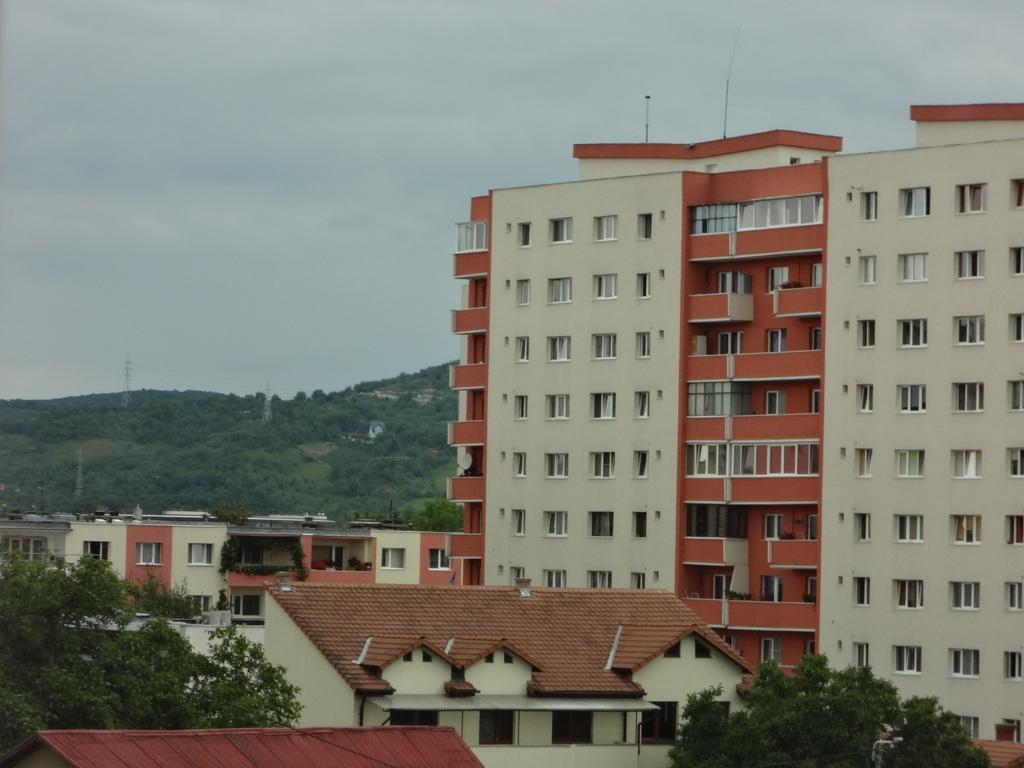What type of structures can be seen in the image? There are buildings and towers in the image. What natural elements are present in the image? There are trees in the image. What architectural features can be observed in the buildings? There are windows in the image. What is the color of the sky in the image? The sky is blue and white in color. What type of shirt is hanging on the tree in the image? There is no shirt hanging on the tree in the image; only buildings, towers, trees, windows, and the sky are present. What type of food can be seen growing on the buildings in the image? There is no food growing on the buildings in the image; only buildings, towers, trees, windows, and the sky are present. 